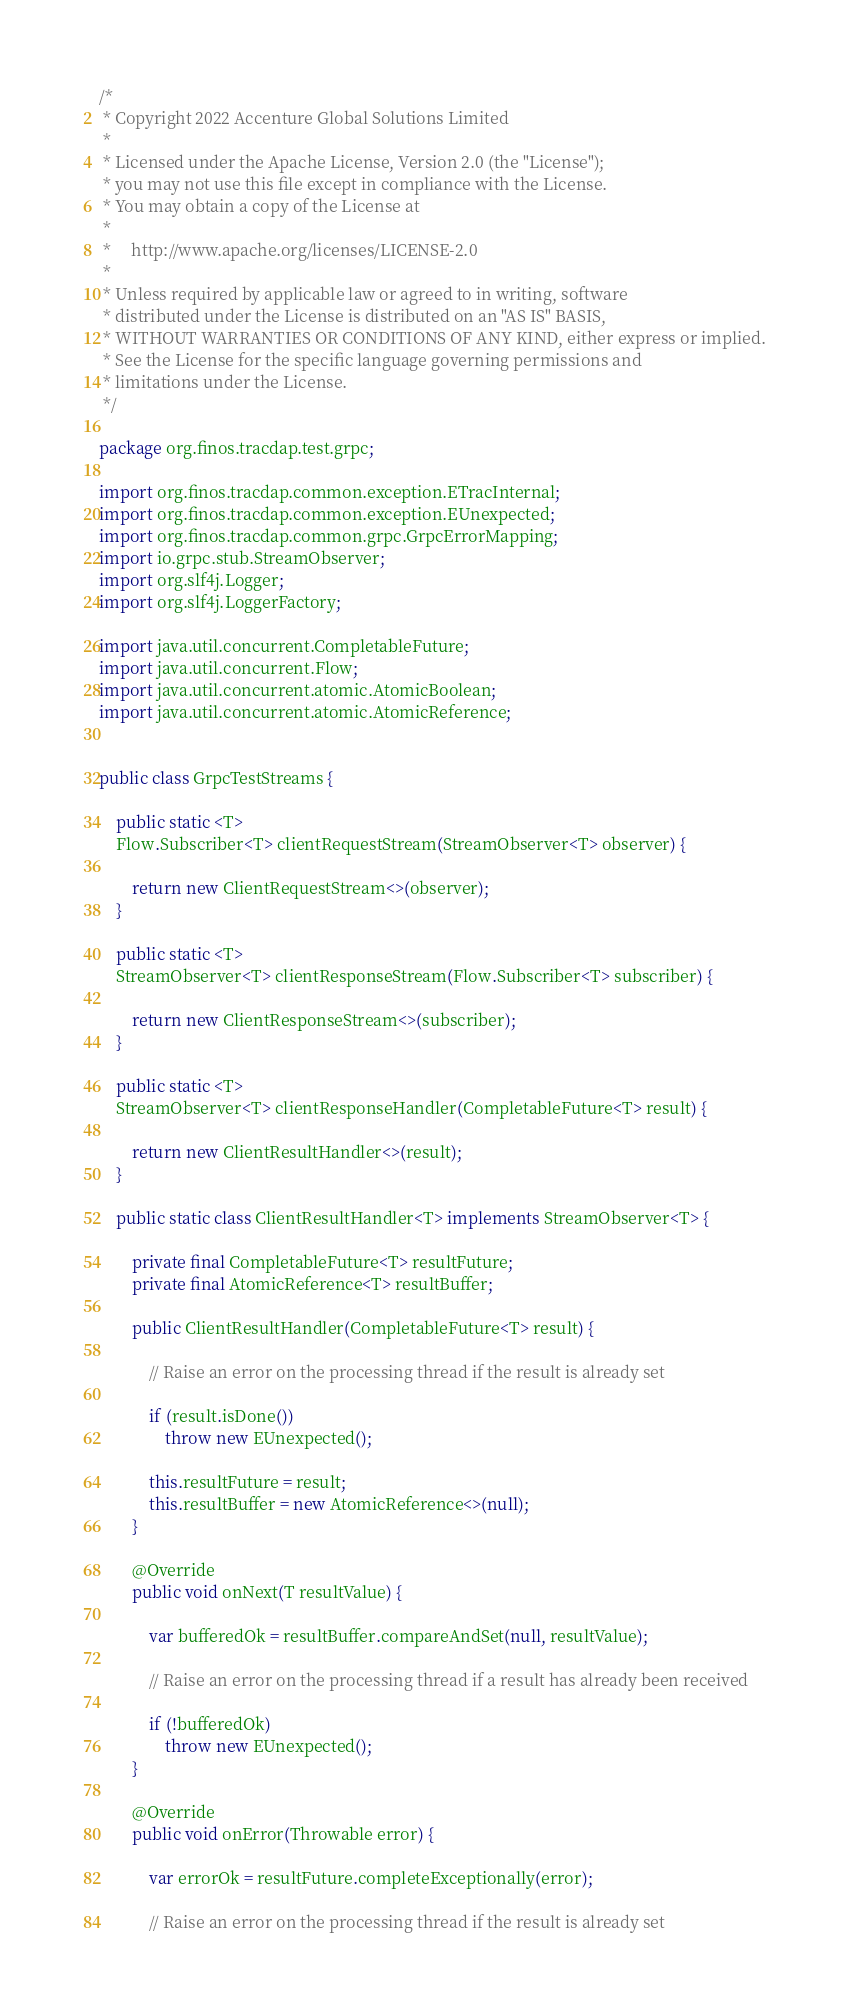Convert code to text. <code><loc_0><loc_0><loc_500><loc_500><_Java_>/*
 * Copyright 2022 Accenture Global Solutions Limited
 *
 * Licensed under the Apache License, Version 2.0 (the "License");
 * you may not use this file except in compliance with the License.
 * You may obtain a copy of the License at
 *
 *     http://www.apache.org/licenses/LICENSE-2.0
 *
 * Unless required by applicable law or agreed to in writing, software
 * distributed under the License is distributed on an "AS IS" BASIS,
 * WITHOUT WARRANTIES OR CONDITIONS OF ANY KIND, either express or implied.
 * See the License for the specific language governing permissions and
 * limitations under the License.
 */

package org.finos.tracdap.test.grpc;

import org.finos.tracdap.common.exception.ETracInternal;
import org.finos.tracdap.common.exception.EUnexpected;
import org.finos.tracdap.common.grpc.GrpcErrorMapping;
import io.grpc.stub.StreamObserver;
import org.slf4j.Logger;
import org.slf4j.LoggerFactory;

import java.util.concurrent.CompletableFuture;
import java.util.concurrent.Flow;
import java.util.concurrent.atomic.AtomicBoolean;
import java.util.concurrent.atomic.AtomicReference;


public class GrpcTestStreams {

    public static <T>
    Flow.Subscriber<T> clientRequestStream(StreamObserver<T> observer) {

        return new ClientRequestStream<>(observer);
    }

    public static <T>
    StreamObserver<T> clientResponseStream(Flow.Subscriber<T> subscriber) {

        return new ClientResponseStream<>(subscriber);
    }

    public static <T>
    StreamObserver<T> clientResponseHandler(CompletableFuture<T> result) {

        return new ClientResultHandler<>(result);
    }

    public static class ClientResultHandler<T> implements StreamObserver<T> {

        private final CompletableFuture<T> resultFuture;
        private final AtomicReference<T> resultBuffer;

        public ClientResultHandler(CompletableFuture<T> result) {

            // Raise an error on the processing thread if the result is already set

            if (result.isDone())
                throw new EUnexpected();

            this.resultFuture = result;
            this.resultBuffer = new AtomicReference<>(null);
        }

        @Override
        public void onNext(T resultValue) {

            var bufferedOk = resultBuffer.compareAndSet(null, resultValue);

            // Raise an error on the processing thread if a result has already been received

            if (!bufferedOk)
                throw new EUnexpected();
        }

        @Override
        public void onError(Throwable error) {

            var errorOk = resultFuture.completeExceptionally(error);

            // Raise an error on the processing thread if the result is already set
</code> 